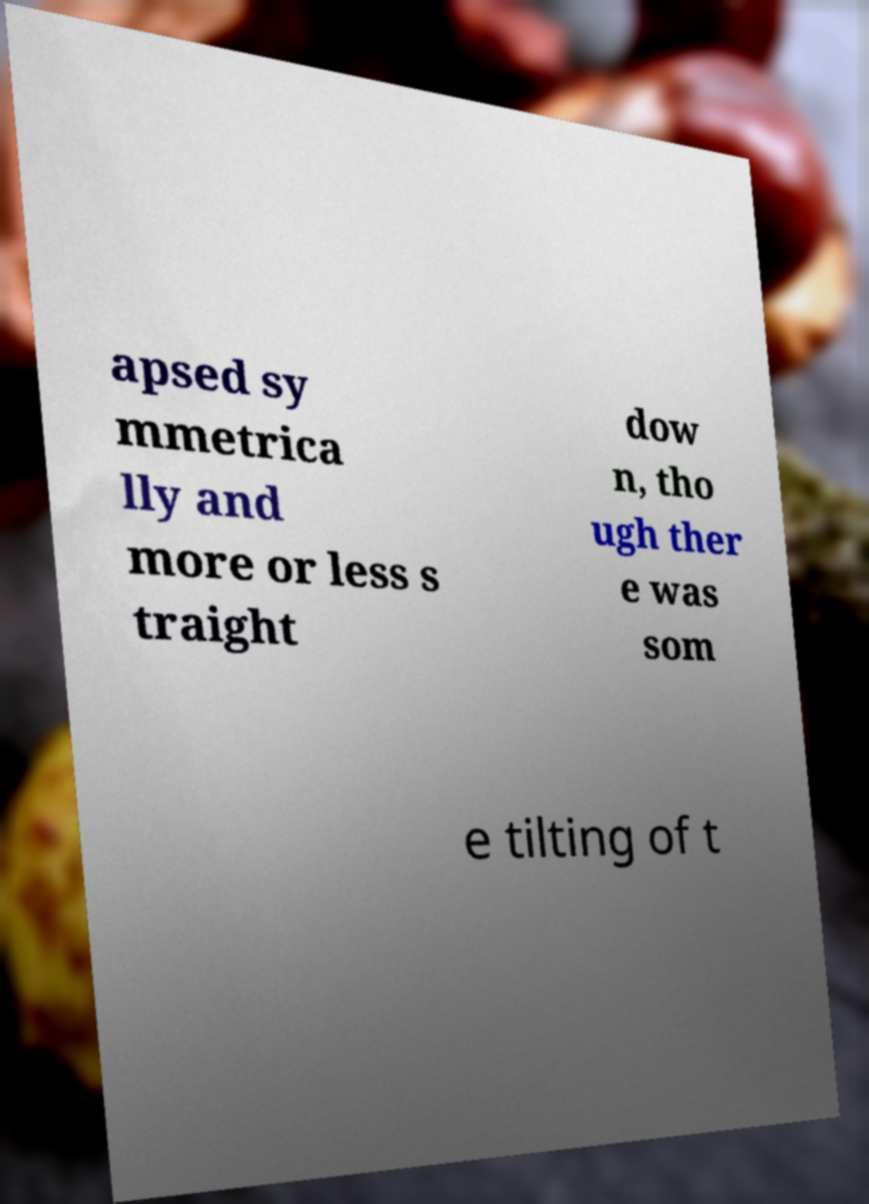Can you read and provide the text displayed in the image?This photo seems to have some interesting text. Can you extract and type it out for me? apsed sy mmetrica lly and more or less s traight dow n, tho ugh ther e was som e tilting of t 